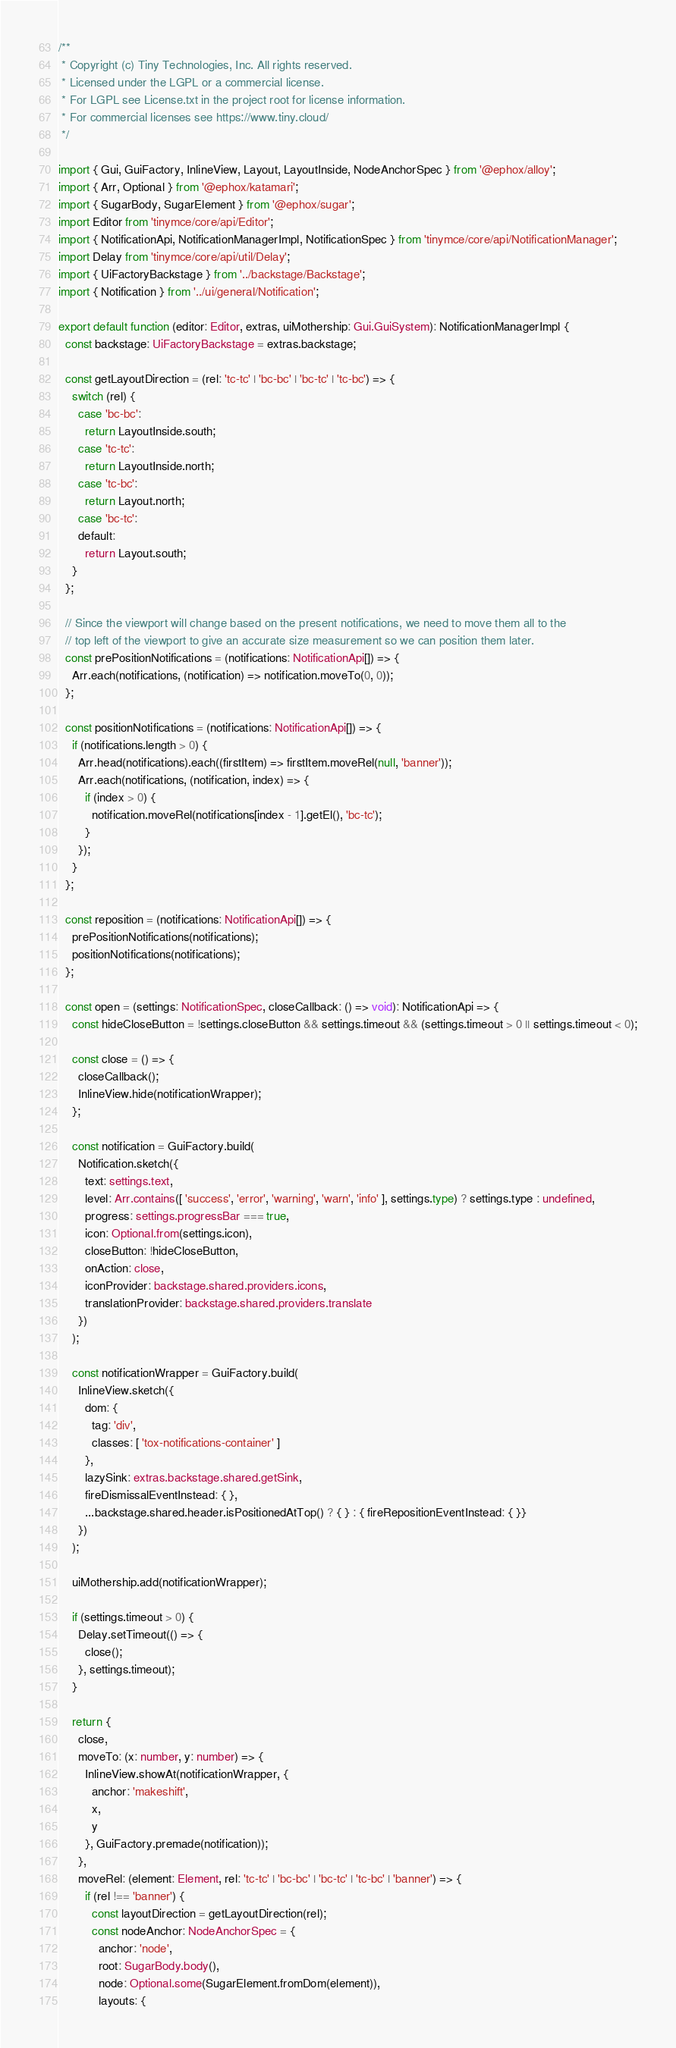Convert code to text. <code><loc_0><loc_0><loc_500><loc_500><_TypeScript_>/**
 * Copyright (c) Tiny Technologies, Inc. All rights reserved.
 * Licensed under the LGPL or a commercial license.
 * For LGPL see License.txt in the project root for license information.
 * For commercial licenses see https://www.tiny.cloud/
 */

import { Gui, GuiFactory, InlineView, Layout, LayoutInside, NodeAnchorSpec } from '@ephox/alloy';
import { Arr, Optional } from '@ephox/katamari';
import { SugarBody, SugarElement } from '@ephox/sugar';
import Editor from 'tinymce/core/api/Editor';
import { NotificationApi, NotificationManagerImpl, NotificationSpec } from 'tinymce/core/api/NotificationManager';
import Delay from 'tinymce/core/api/util/Delay';
import { UiFactoryBackstage } from '../backstage/Backstage';
import { Notification } from '../ui/general/Notification';

export default function (editor: Editor, extras, uiMothership: Gui.GuiSystem): NotificationManagerImpl {
  const backstage: UiFactoryBackstage = extras.backstage;

  const getLayoutDirection = (rel: 'tc-tc' | 'bc-bc' | 'bc-tc' | 'tc-bc') => {
    switch (rel) {
      case 'bc-bc':
        return LayoutInside.south;
      case 'tc-tc':
        return LayoutInside.north;
      case 'tc-bc':
        return Layout.north;
      case 'bc-tc':
      default:
        return Layout.south;
    }
  };

  // Since the viewport will change based on the present notifications, we need to move them all to the
  // top left of the viewport to give an accurate size measurement so we can position them later.
  const prePositionNotifications = (notifications: NotificationApi[]) => {
    Arr.each(notifications, (notification) => notification.moveTo(0, 0));
  };

  const positionNotifications = (notifications: NotificationApi[]) => {
    if (notifications.length > 0) {
      Arr.head(notifications).each((firstItem) => firstItem.moveRel(null, 'banner'));
      Arr.each(notifications, (notification, index) => {
        if (index > 0) {
          notification.moveRel(notifications[index - 1].getEl(), 'bc-tc');
        }
      });
    }
  };

  const reposition = (notifications: NotificationApi[]) => {
    prePositionNotifications(notifications);
    positionNotifications(notifications);
  };

  const open = (settings: NotificationSpec, closeCallback: () => void): NotificationApi => {
    const hideCloseButton = !settings.closeButton && settings.timeout && (settings.timeout > 0 || settings.timeout < 0);

    const close = () => {
      closeCallback();
      InlineView.hide(notificationWrapper);
    };

    const notification = GuiFactory.build(
      Notification.sketch({
        text: settings.text,
        level: Arr.contains([ 'success', 'error', 'warning', 'warn', 'info' ], settings.type) ? settings.type : undefined,
        progress: settings.progressBar === true,
        icon: Optional.from(settings.icon),
        closeButton: !hideCloseButton,
        onAction: close,
        iconProvider: backstage.shared.providers.icons,
        translationProvider: backstage.shared.providers.translate
      })
    );

    const notificationWrapper = GuiFactory.build(
      InlineView.sketch({
        dom: {
          tag: 'div',
          classes: [ 'tox-notifications-container' ]
        },
        lazySink: extras.backstage.shared.getSink,
        fireDismissalEventInstead: { },
        ...backstage.shared.header.isPositionedAtTop() ? { } : { fireRepositionEventInstead: { }}
      })
    );

    uiMothership.add(notificationWrapper);

    if (settings.timeout > 0) {
      Delay.setTimeout(() => {
        close();
      }, settings.timeout);
    }

    return {
      close,
      moveTo: (x: number, y: number) => {
        InlineView.showAt(notificationWrapper, {
          anchor: 'makeshift',
          x,
          y
        }, GuiFactory.premade(notification));
      },
      moveRel: (element: Element, rel: 'tc-tc' | 'bc-bc' | 'bc-tc' | 'tc-bc' | 'banner') => {
        if (rel !== 'banner') {
          const layoutDirection = getLayoutDirection(rel);
          const nodeAnchor: NodeAnchorSpec = {
            anchor: 'node',
            root: SugarBody.body(),
            node: Optional.some(SugarElement.fromDom(element)),
            layouts: {</code> 